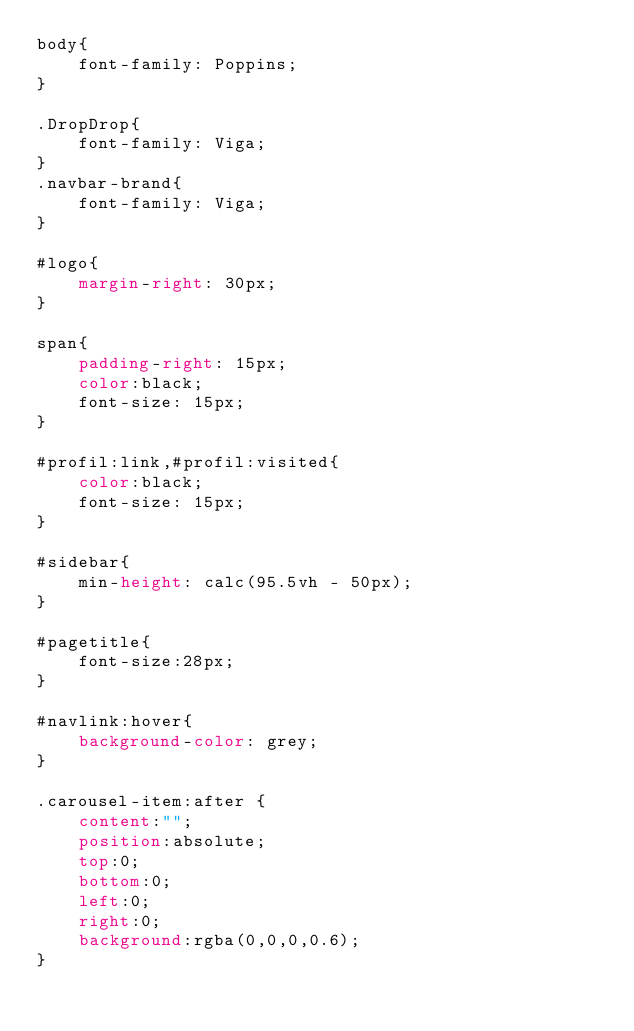<code> <loc_0><loc_0><loc_500><loc_500><_CSS_>body{
    font-family: Poppins;
}

.DropDrop{
    font-family: Viga;
}
.navbar-brand{
    font-family: Viga;
}

#logo{
    margin-right: 30px;
}

span{
    padding-right: 15px;
    color:black;
    font-size: 15px;
}

#profil:link,#profil:visited{
    color:black;
    font-size: 15px;
}

#sidebar{
    min-height: calc(95.5vh - 50px);
}

#pagetitle{
    font-size:28px;
}

#navlink:hover{
    background-color: grey;
}

.carousel-item:after {
    content:"";
    position:absolute;
    top:0;
    bottom:0;
    left:0;
    right:0;
    background:rgba(0,0,0,0.6);
}</code> 